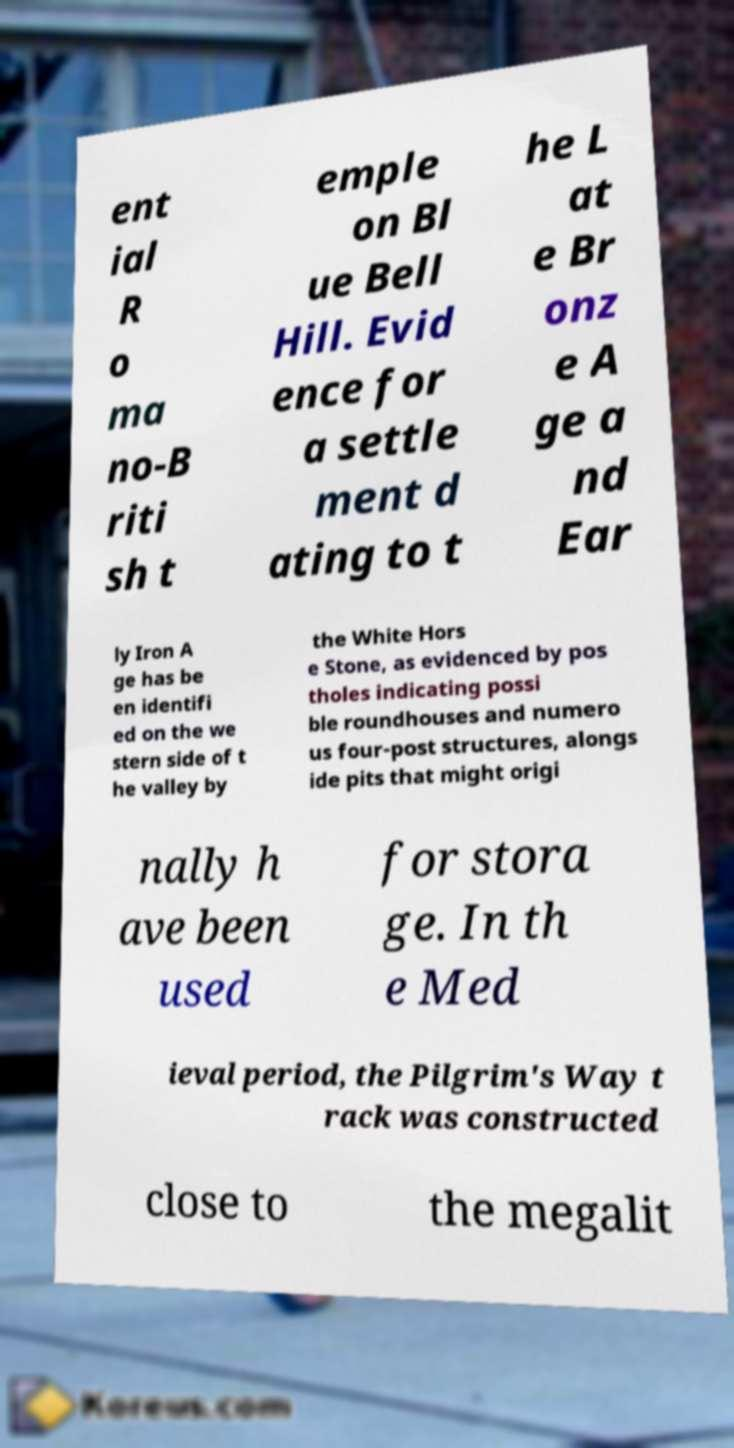Please identify and transcribe the text found in this image. ent ial R o ma no-B riti sh t emple on Bl ue Bell Hill. Evid ence for a settle ment d ating to t he L at e Br onz e A ge a nd Ear ly Iron A ge has be en identifi ed on the we stern side of t he valley by the White Hors e Stone, as evidenced by pos tholes indicating possi ble roundhouses and numero us four-post structures, alongs ide pits that might origi nally h ave been used for stora ge. In th e Med ieval period, the Pilgrim's Way t rack was constructed close to the megalit 